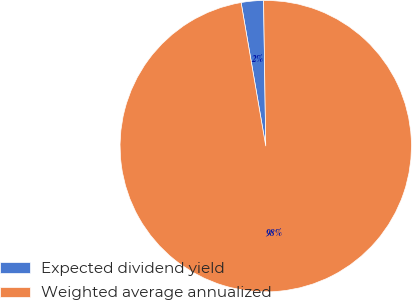<chart> <loc_0><loc_0><loc_500><loc_500><pie_chart><fcel>Expected dividend yield<fcel>Weighted average annualized<nl><fcel>2.47%<fcel>97.53%<nl></chart> 